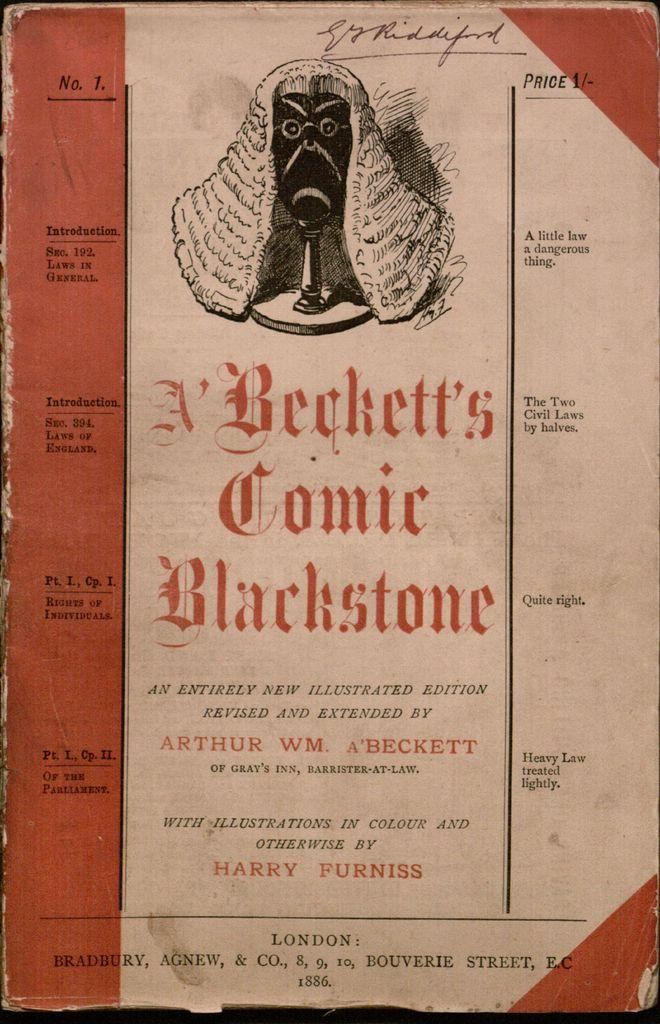<image>
Present a compact description of the photo's key features. A cover of Beckett's Comic Blackstone with a person wearing a wig. 